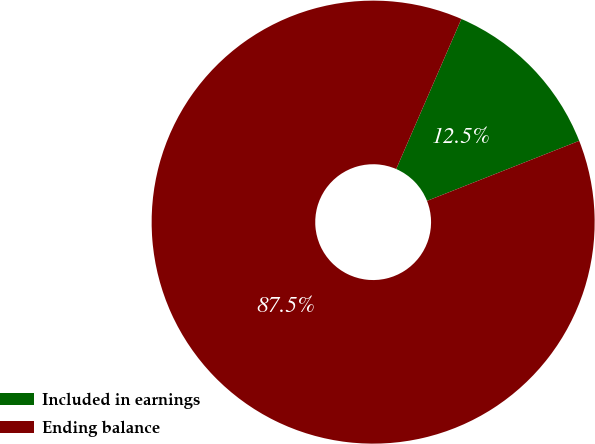Convert chart. <chart><loc_0><loc_0><loc_500><loc_500><pie_chart><fcel>Included in earnings<fcel>Ending balance<nl><fcel>12.5%<fcel>87.5%<nl></chart> 